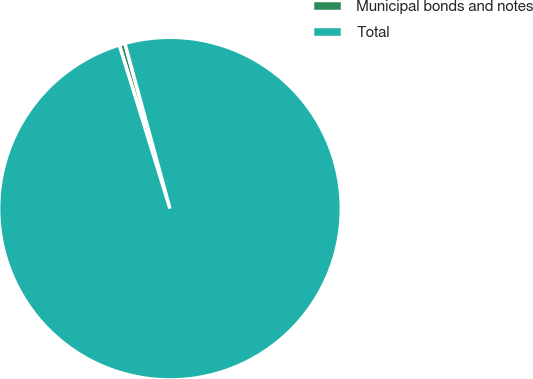<chart> <loc_0><loc_0><loc_500><loc_500><pie_chart><fcel>Municipal bonds and notes<fcel>Total<nl><fcel>0.54%<fcel>99.46%<nl></chart> 